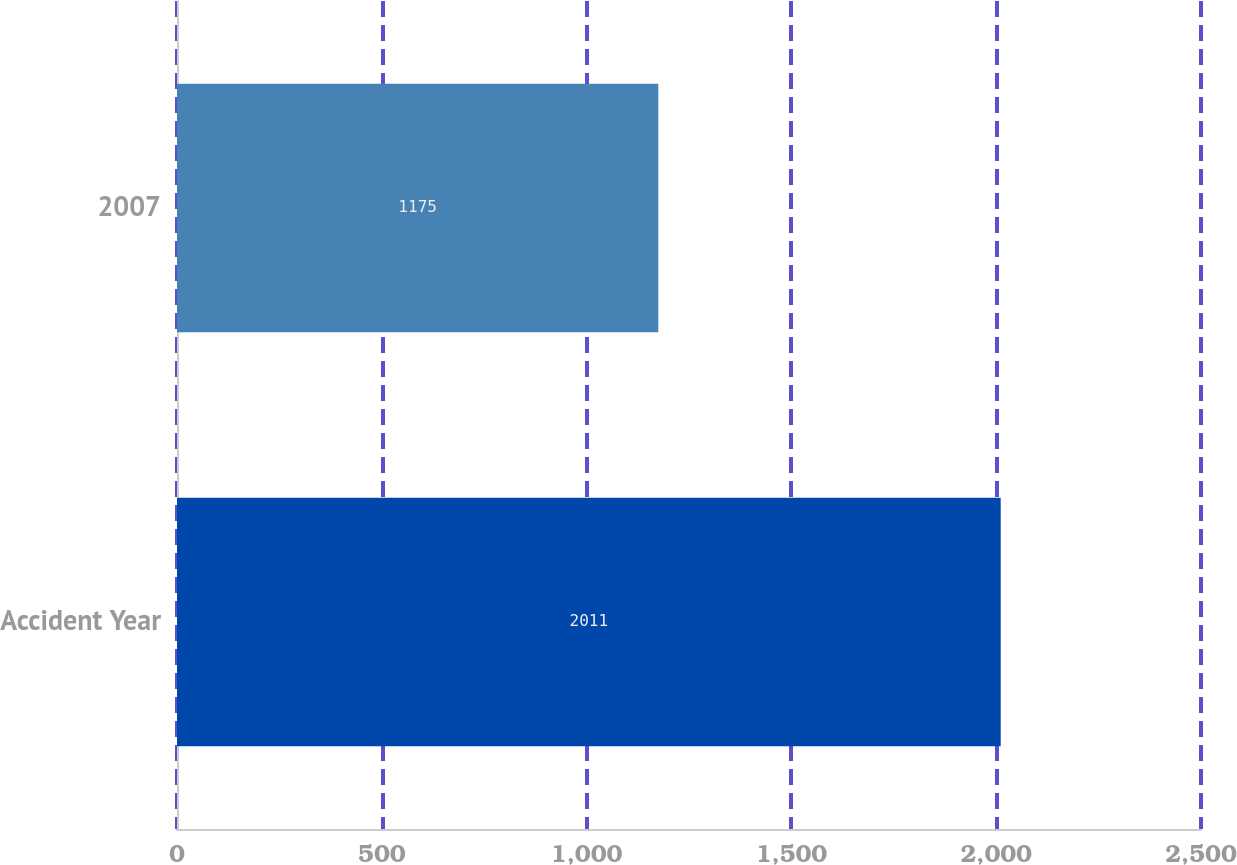Convert chart to OTSL. <chart><loc_0><loc_0><loc_500><loc_500><bar_chart><fcel>Accident Year<fcel>2007<nl><fcel>2011<fcel>1175<nl></chart> 